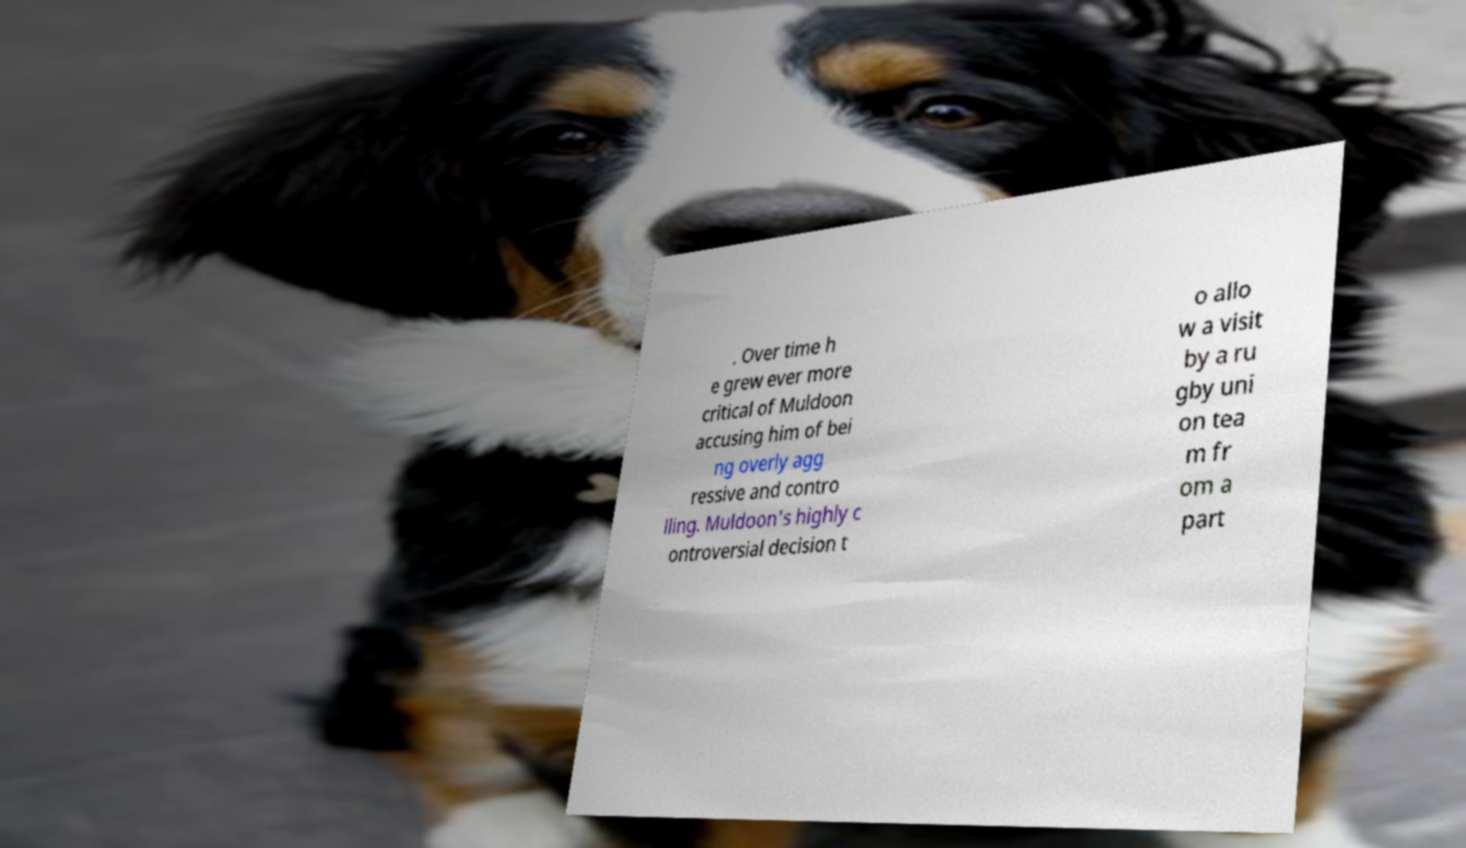Could you assist in decoding the text presented in this image and type it out clearly? . Over time h e grew ever more critical of Muldoon accusing him of bei ng overly agg ressive and contro lling. Muldoon's highly c ontroversial decision t o allo w a visit by a ru gby uni on tea m fr om a part 